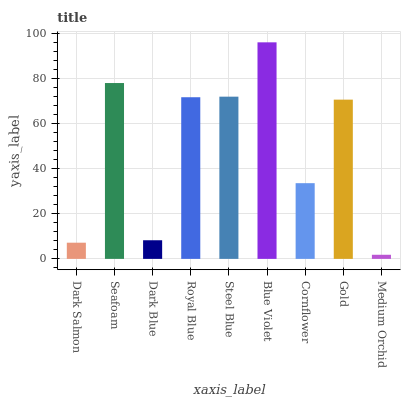Is Medium Orchid the minimum?
Answer yes or no. Yes. Is Blue Violet the maximum?
Answer yes or no. Yes. Is Seafoam the minimum?
Answer yes or no. No. Is Seafoam the maximum?
Answer yes or no. No. Is Seafoam greater than Dark Salmon?
Answer yes or no. Yes. Is Dark Salmon less than Seafoam?
Answer yes or no. Yes. Is Dark Salmon greater than Seafoam?
Answer yes or no. No. Is Seafoam less than Dark Salmon?
Answer yes or no. No. Is Gold the high median?
Answer yes or no. Yes. Is Gold the low median?
Answer yes or no. Yes. Is Seafoam the high median?
Answer yes or no. No. Is Seafoam the low median?
Answer yes or no. No. 